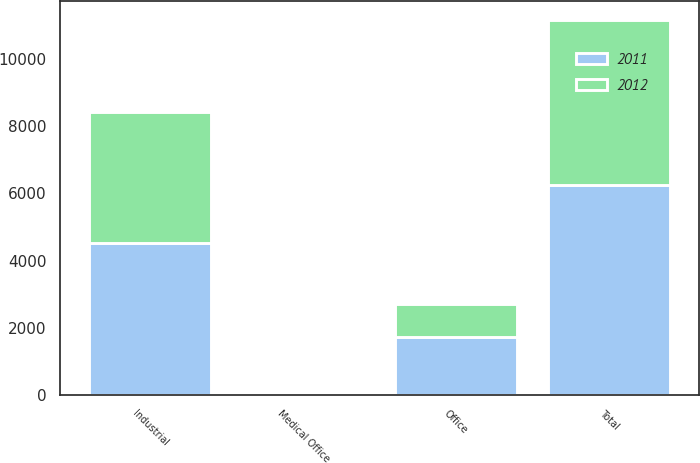<chart> <loc_0><loc_0><loc_500><loc_500><stacked_bar_chart><ecel><fcel>Industrial<fcel>Office<fcel>Medical Office<fcel>Total<nl><fcel>2012<fcel>3900<fcel>972<fcel>39<fcel>4911<nl><fcel>2011<fcel>4512<fcel>1728<fcel>14<fcel>6256<nl></chart> 